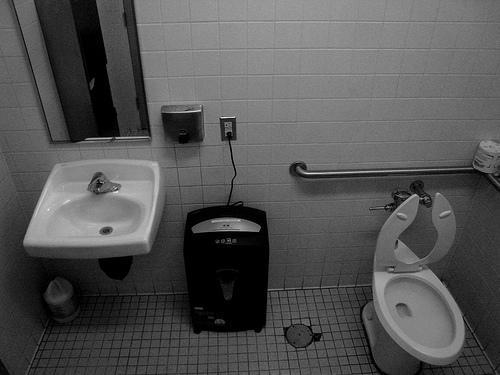How many paper shredders are there?
Give a very brief answer. 1. 